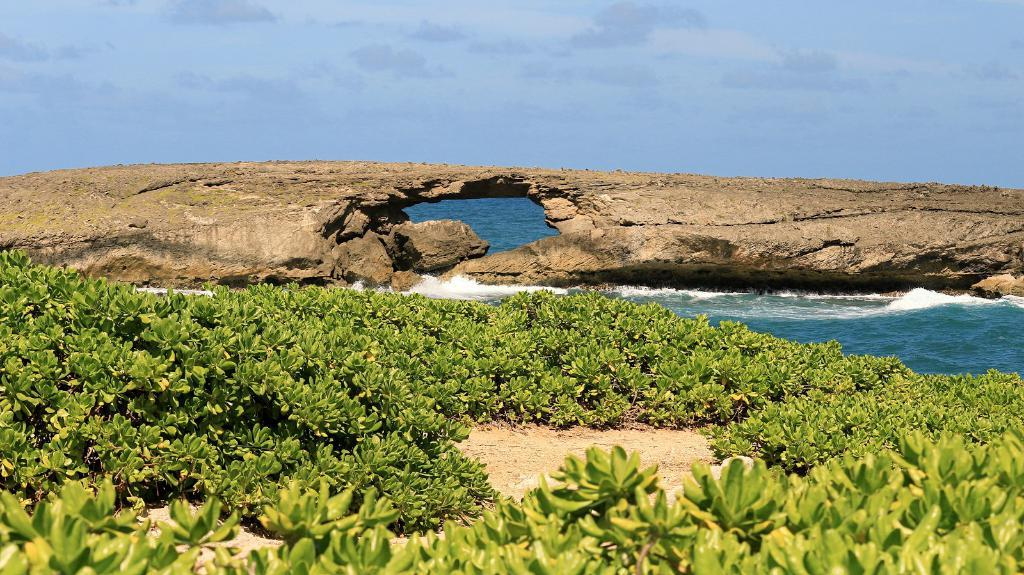What type of vegetation is present at the bottom of the image? There are small plants on the ground at the bottom of the image. What can be seen behind the ground in the image? There is water visible behind the ground. Can you describe a feature of the water in the image? There is a rock with a hole in the water. What is visible at the top of the image? The sky is visible at the top of the image. What type of polish is used on the brass objects in the image? There are no brass objects present in the image. 